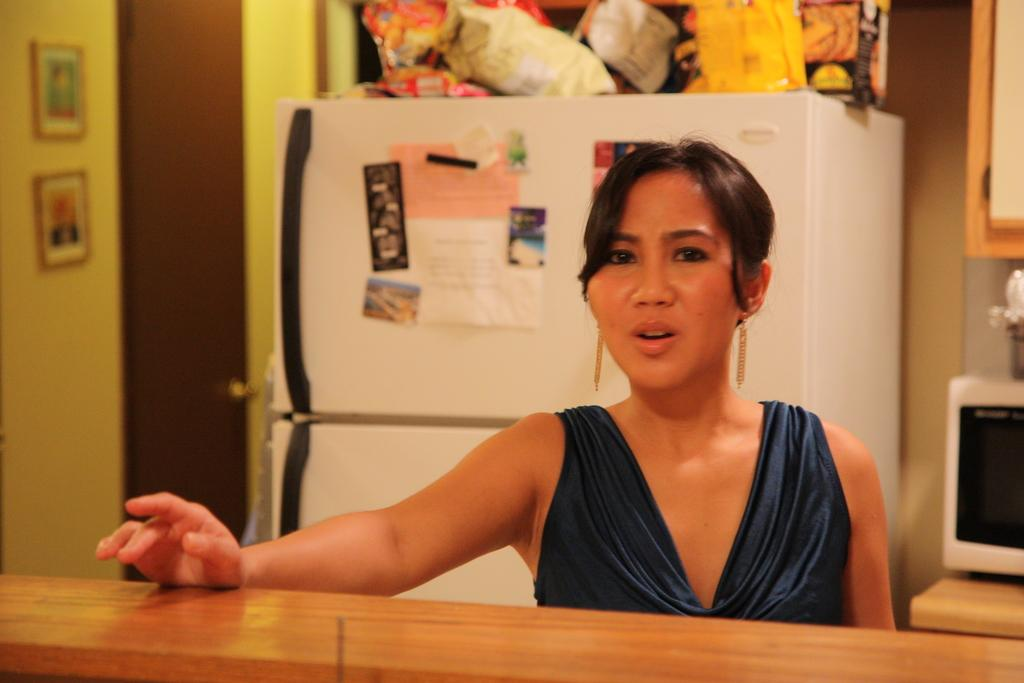Who is in front of the wooden wall in the image? There is a lady in front of the wooden wall in the image. What can be seen on the cupboard in the image? There are objects on the cupboard in the image. What can be seen on the table in the image? There are objects on the table in the image. What is attached to the wall in the image? There are frames attached to the wall in the image. What is attached to the door in the image? There are frames attached to the door in the image. How many robins are sitting on the frames in the image? There are no robins present in the image; it features a lady, objects, and frames. What type of writing instrument is used by the lady in the image? There is no indication of a writing instrument in the image, such as a quill. 